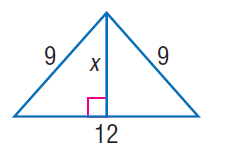Answer the mathemtical geometry problem and directly provide the correct option letter.
Question: Find x.
Choices: A: 3 \sqrt { 5 } B: 4 \sqrt { 5 } C: 5 \sqrt { 5 } D: 6 \sqrt { 5 } A 